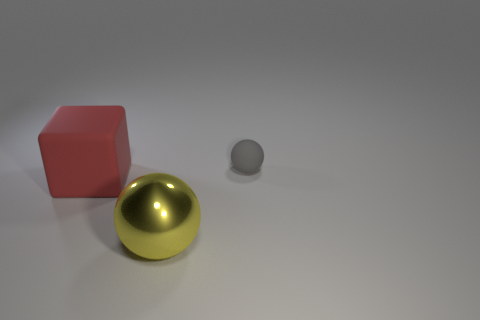Subtract all blue spheres. Subtract all cyan cylinders. How many spheres are left? 2 Add 2 brown rubber balls. How many objects exist? 5 Subtract all cubes. How many objects are left? 2 Subtract all large yellow shiny balls. Subtract all small gray matte objects. How many objects are left? 1 Add 3 metal objects. How many metal objects are left? 4 Add 1 metal things. How many metal things exist? 2 Subtract 0 yellow cubes. How many objects are left? 3 